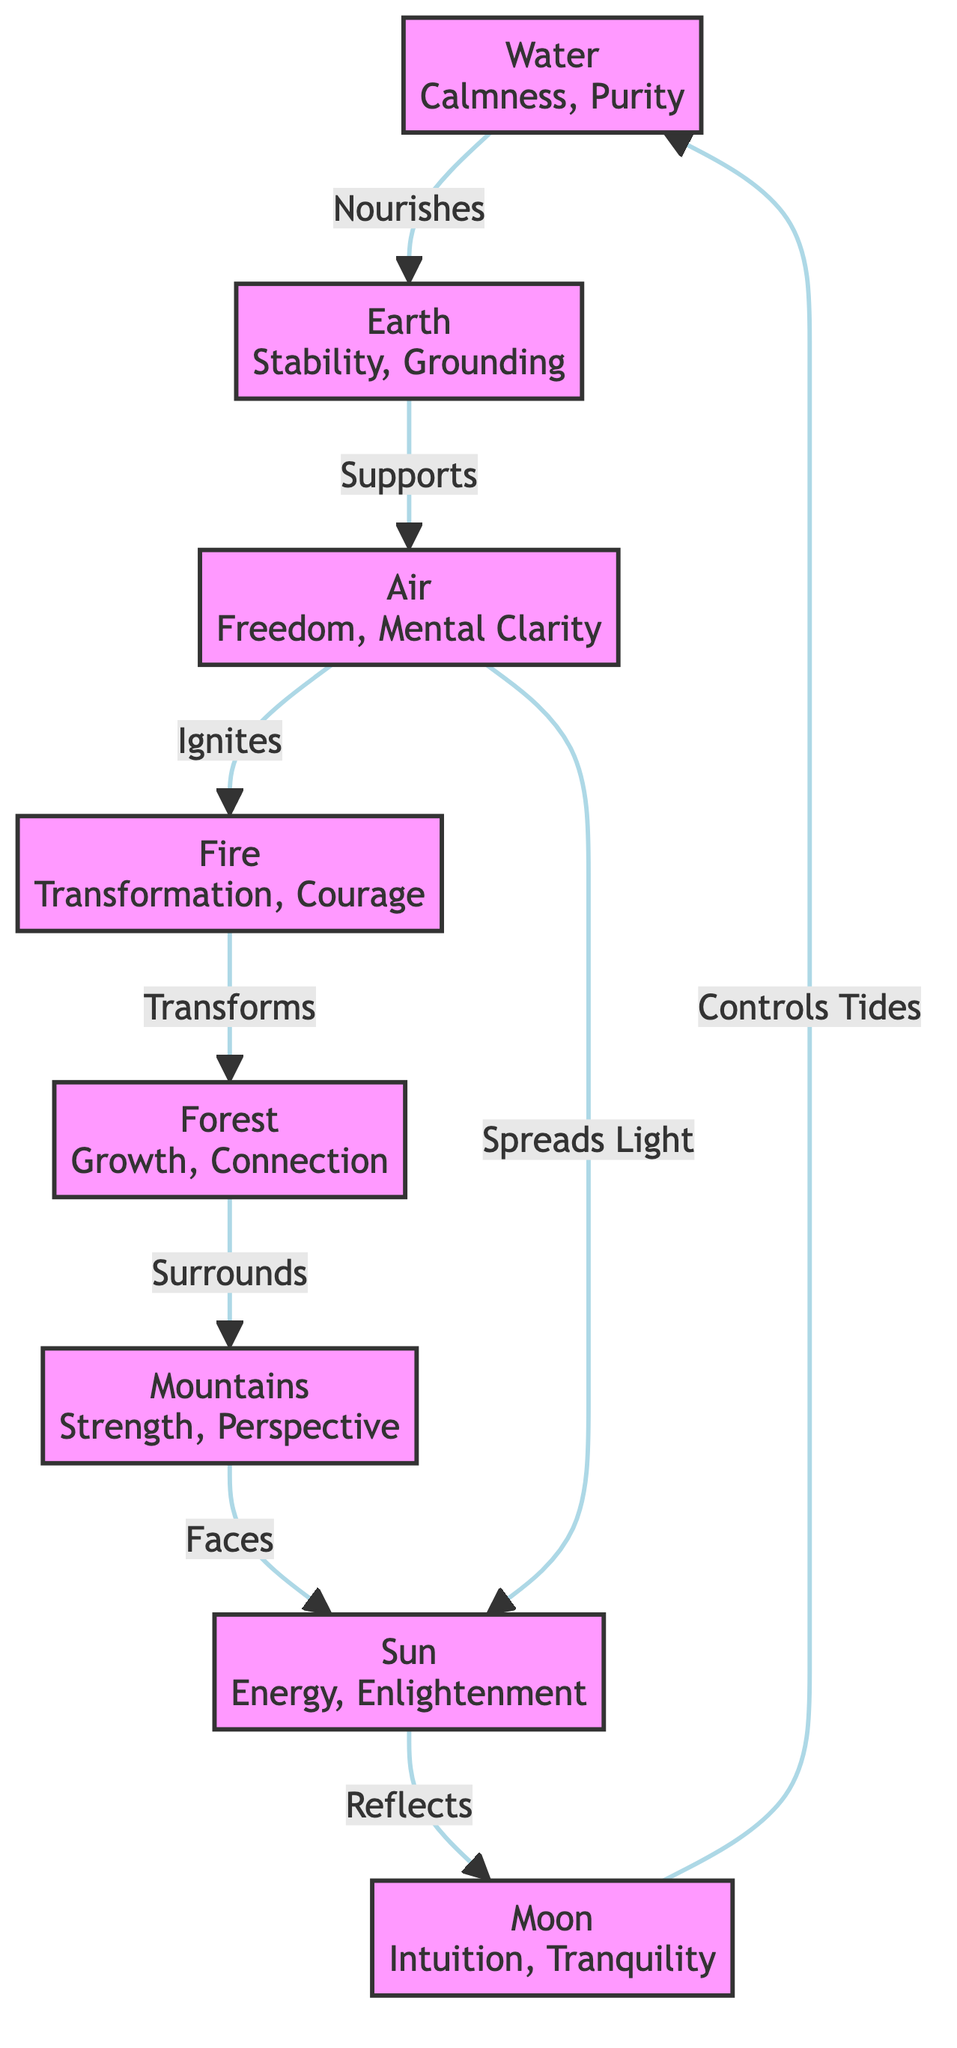What is the symbolism of Water? According to the diagram, Water is associated with "Calmness, Purity, Adaptability". This information can be found by looking directly at the node for Water in the diagram.
Answer: Calmness, Purity, Adaptability How many elements are in the network? By counting the nodes listed in the diagram, we see there are 8 distinct elements present. Each unique node represents an element in the network.
Answer: 8 What relationship does Fire have with Forest? The diagram shows that Fire "Transforms" Forest, indicating the relationship between these two nodes. This connection is represented by an edge linking them in the diagram.
Answer: Transforms Which element is connected to the Moon? The Moon has two connections in the diagram: one to the Sun (Reflects) and one to Water (Controls Tides). Hence, the elements directly connected to the Moon are Sun and Water.
Answer: Sun, Water What does Air spread to the Sun? The diagram indicates that Air "Spreads Light" to the Sun. This relationship is shown as a direct edge going from Air to Sun.
Answer: Spreads Light What does Mountains face? According to the diagram, Mountains "Faces" the Sun, showing the direction of their relationship. This is indicated by the edge linking these two nodes.
Answer: Sun Which element nourishes Earth? Water nourishes Earth, as represented by the directed edge connecting Water to Earth with the label "Nourishes". This clearly shows the relationship between the two elements.
Answer: Water 